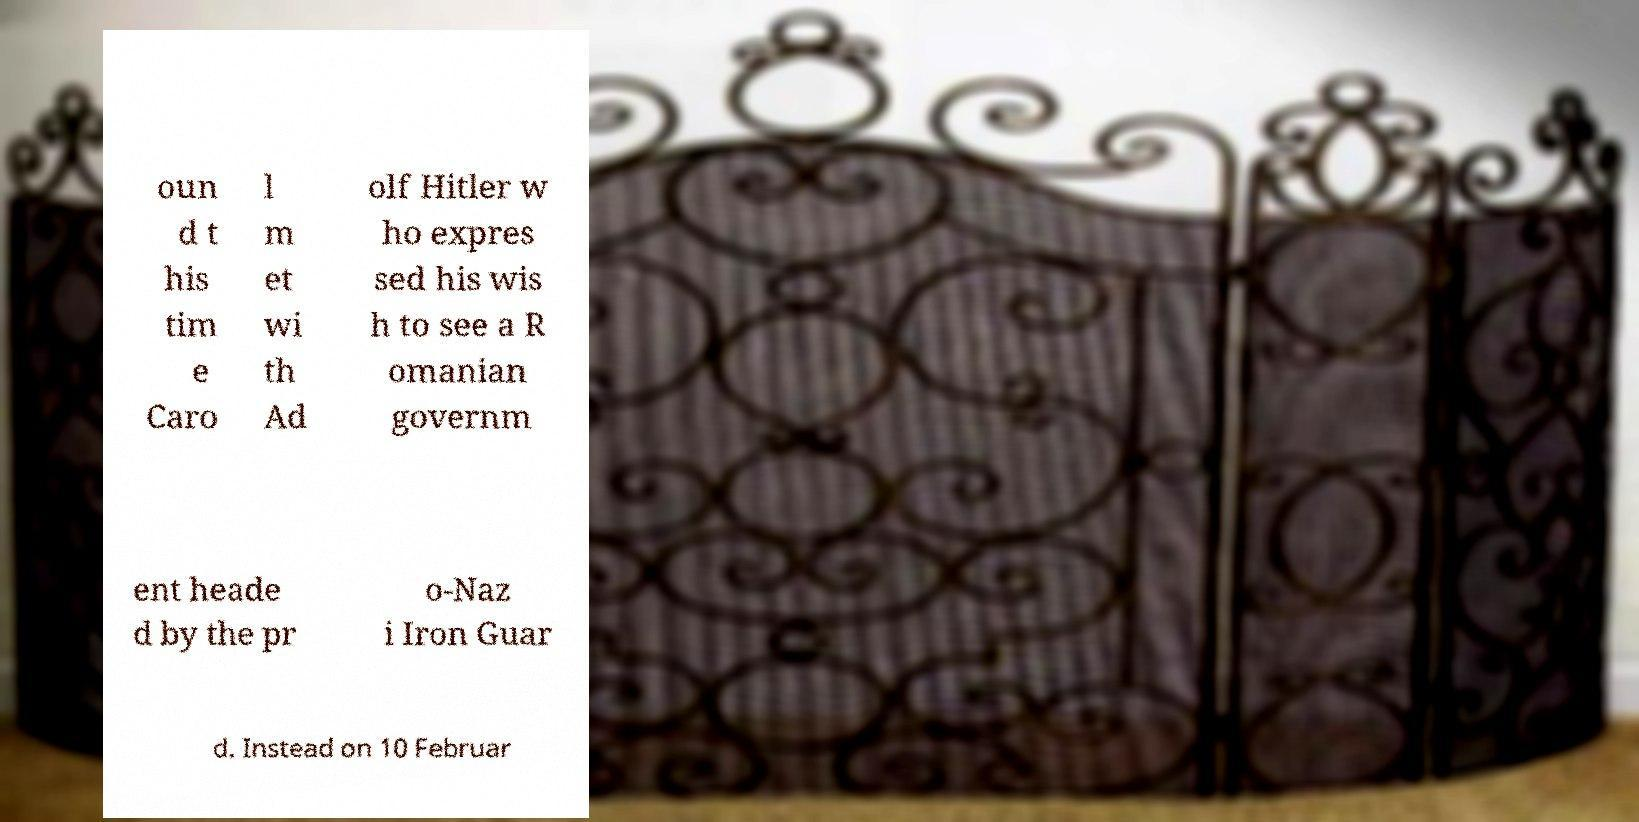Could you extract and type out the text from this image? oun d t his tim e Caro l m et wi th Ad olf Hitler w ho expres sed his wis h to see a R omanian governm ent heade d by the pr o-Naz i Iron Guar d. Instead on 10 Februar 